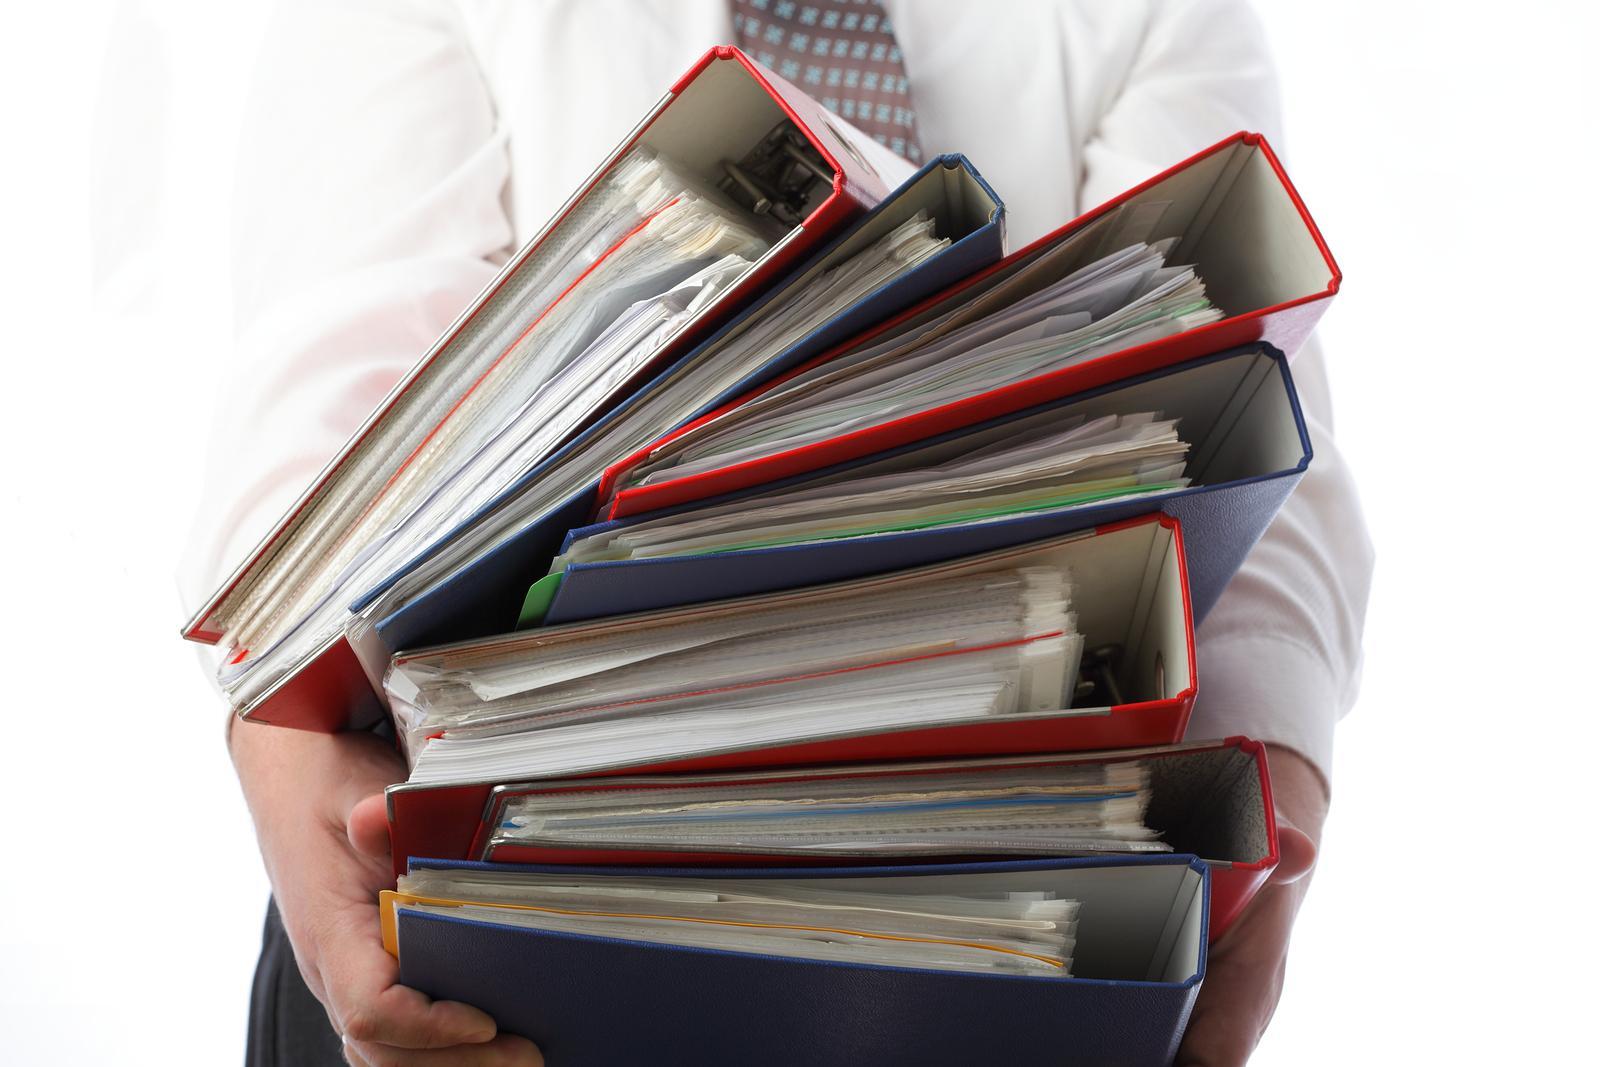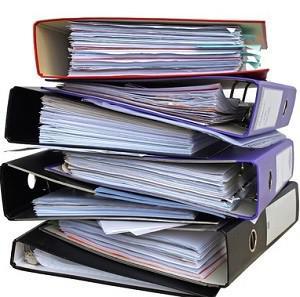The first image is the image on the left, the second image is the image on the right. Evaluate the accuracy of this statement regarding the images: "All of the binders are stacked with only the ends showing.". Is it true? Answer yes or no. Yes. The first image is the image on the left, the second image is the image on the right. Given the left and right images, does the statement "Both of the images show binders full of papers." hold true? Answer yes or no. Yes. 